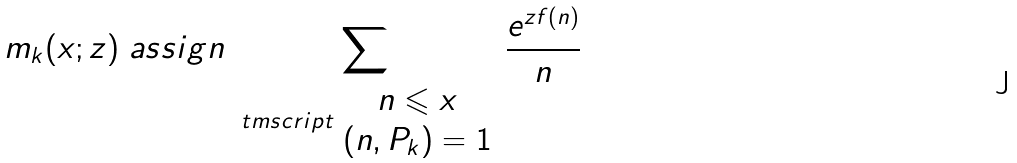<formula> <loc_0><loc_0><loc_500><loc_500>m _ { k } ( x ; z ) \ a s s i g n \sum _ { \ t m s c r i p t { \begin{array} { c } n \leqslant x \\ ( n , P _ { k } ) = 1 \end{array} } } \frac { e ^ { z f ( n ) } } { n }</formula> 